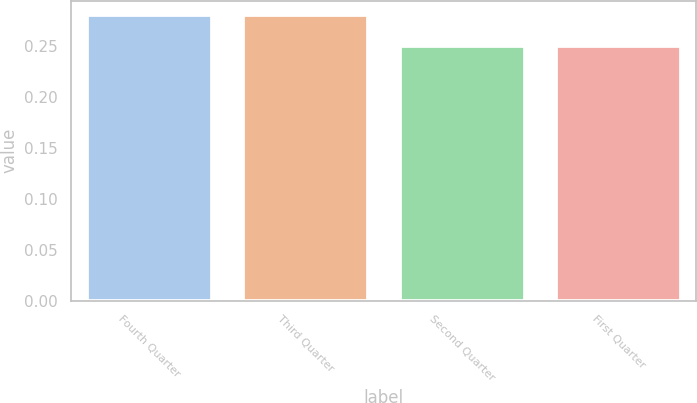<chart> <loc_0><loc_0><loc_500><loc_500><bar_chart><fcel>Fourth Quarter<fcel>Third Quarter<fcel>Second Quarter<fcel>First Quarter<nl><fcel>0.28<fcel>0.28<fcel>0.25<fcel>0.25<nl></chart> 